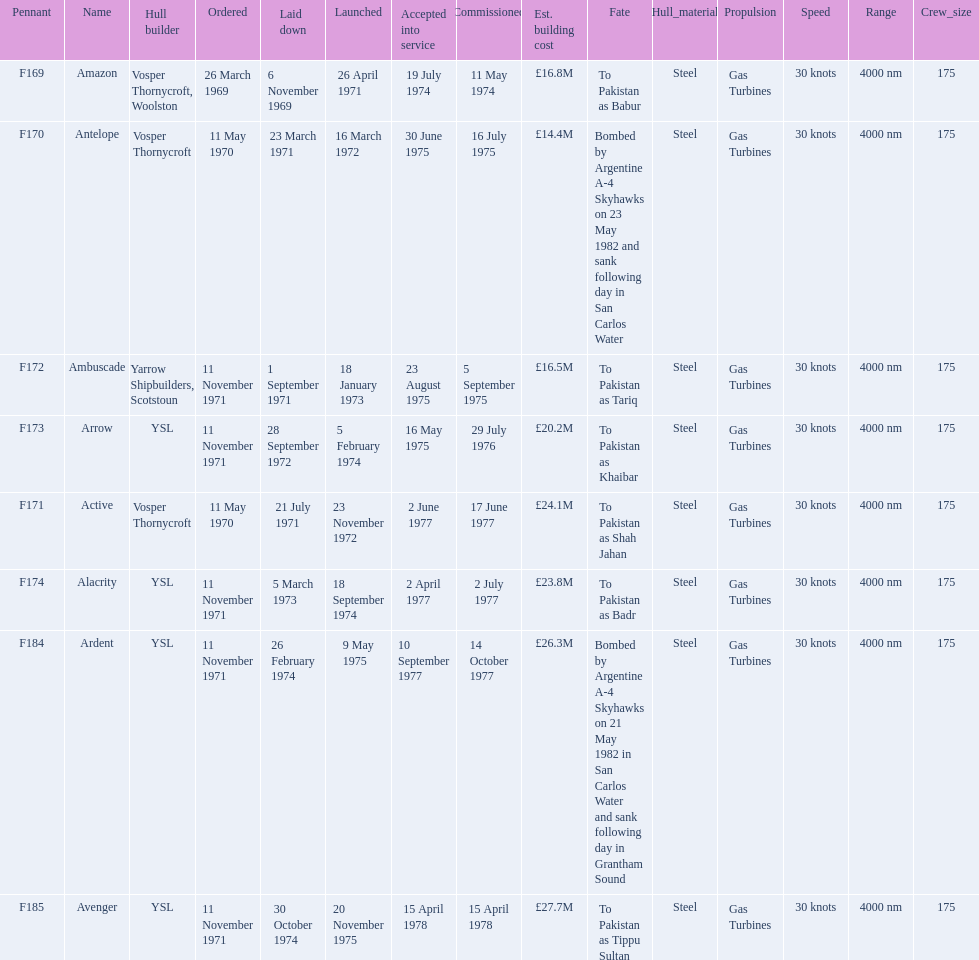What were the estimated building costs of the frigates? £16.8M, £14.4M, £16.5M, £20.2M, £24.1M, £23.8M, £26.3M, £27.7M. Which of these is the largest? £27.7M. What ship name does that correspond to? Avenger. 